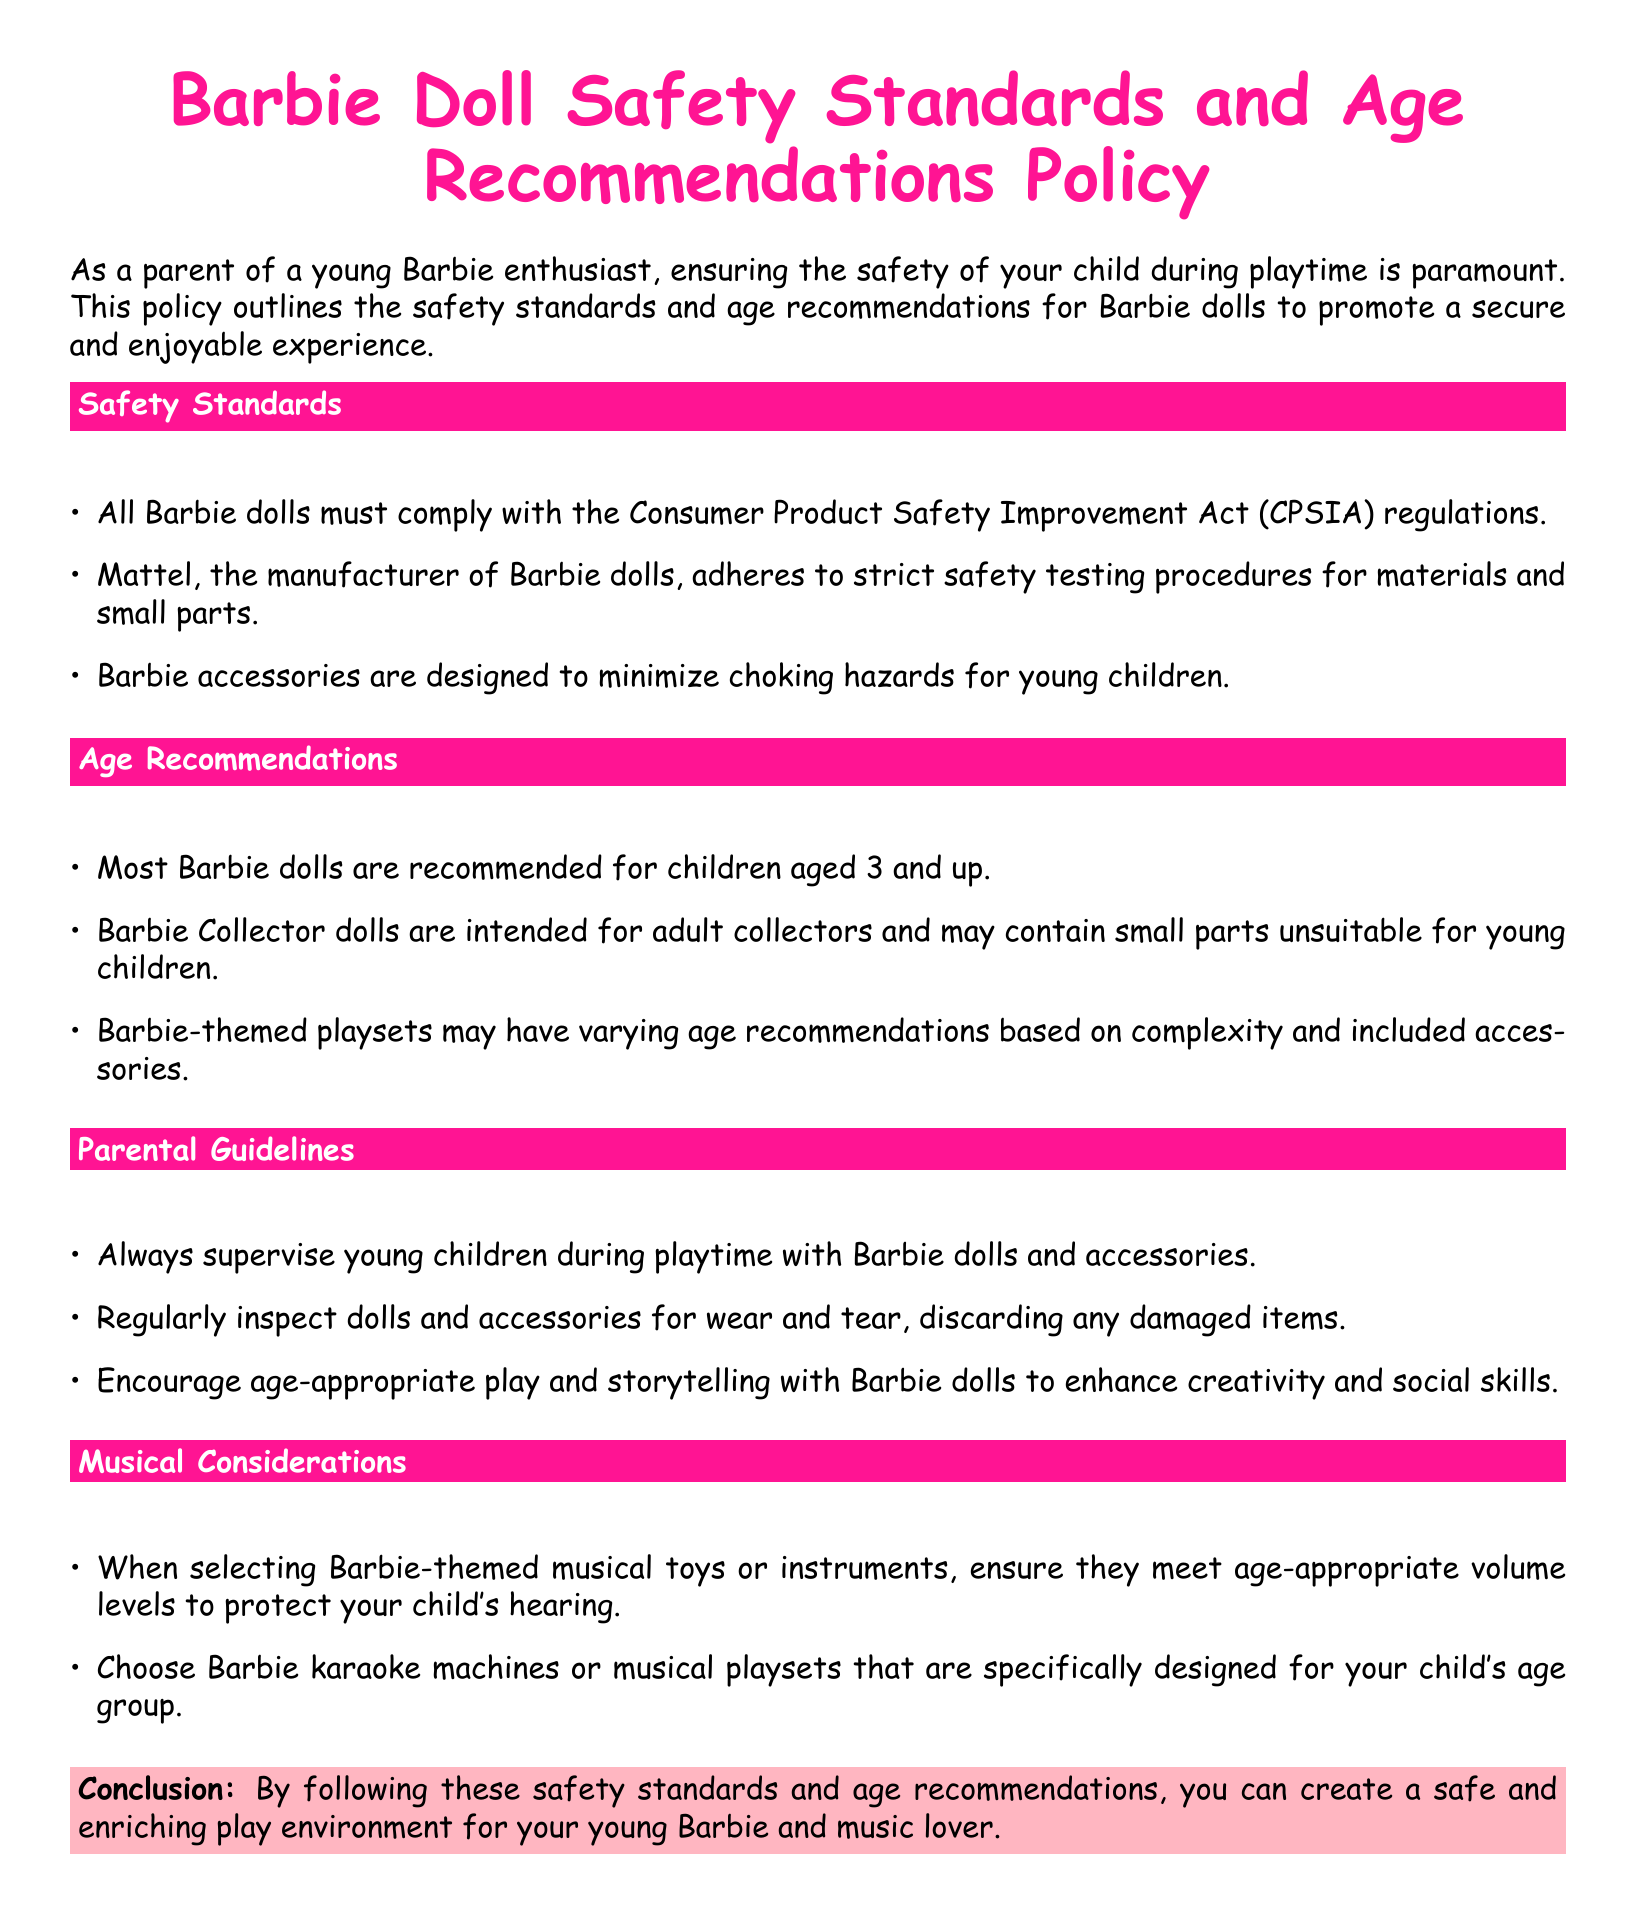What are the safety standards for Barbie dolls? The safety standards for Barbie dolls include compliance with the CPSIA regulations and adherence to safety testing procedures by Mattel.
Answer: CPSIA regulations What is the recommended age for most Barbie dolls? The document states that most Barbie dolls are recommended for a specific minimum age.
Answer: 3 and up What should parents do to ensure safe play? Parents are guided to supervise children during playtime and regularly inspect dolls and accessories.
Answer: Supervise What is a notable feature of Barbie accessories? A specific design consideration is mentioned regarding choking hazards for young children.
Answer: Minimize choking hazards What are Barbie Collector dolls intended for? The document specifies a particular audience for Barbie Collector dolls due to a safety reason.
Answer: Adult collectors How can parents enhance creativity during play? The document suggests a particular type of play that encourages creativity and social skills.
Answer: Age-appropriate play What volume levels should musical toys meet? When selecting musical toys, there is a specific consideration mentioned to protect children.
Answer: Age-appropriate volume levels What should parents do with damaged items? The parents are advised to take a specific action regarding wear and tear in play items.
Answer: Discard What is the conclusion regarding safety standards? The conclusion emphasizes a certain outcome if the guidelines are followed.
Answer: Safe and enriching play environment 